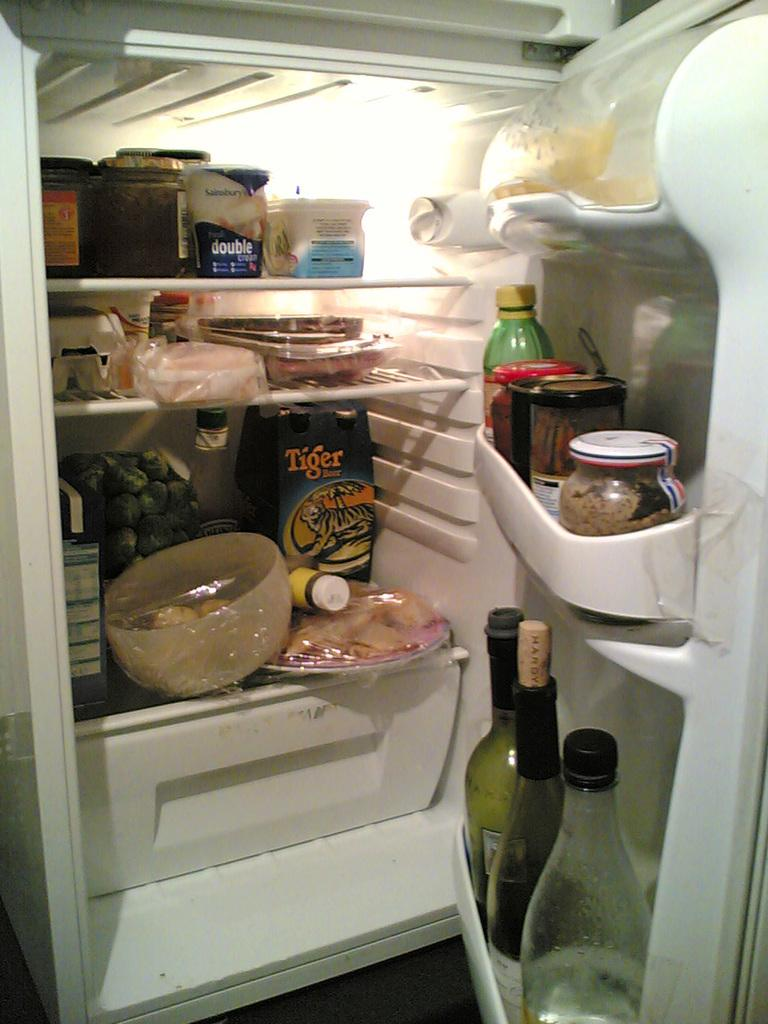<image>
Relay a brief, clear account of the picture shown. The inside of a refrigerator with a Tiger carton product on the bottom shelf. 